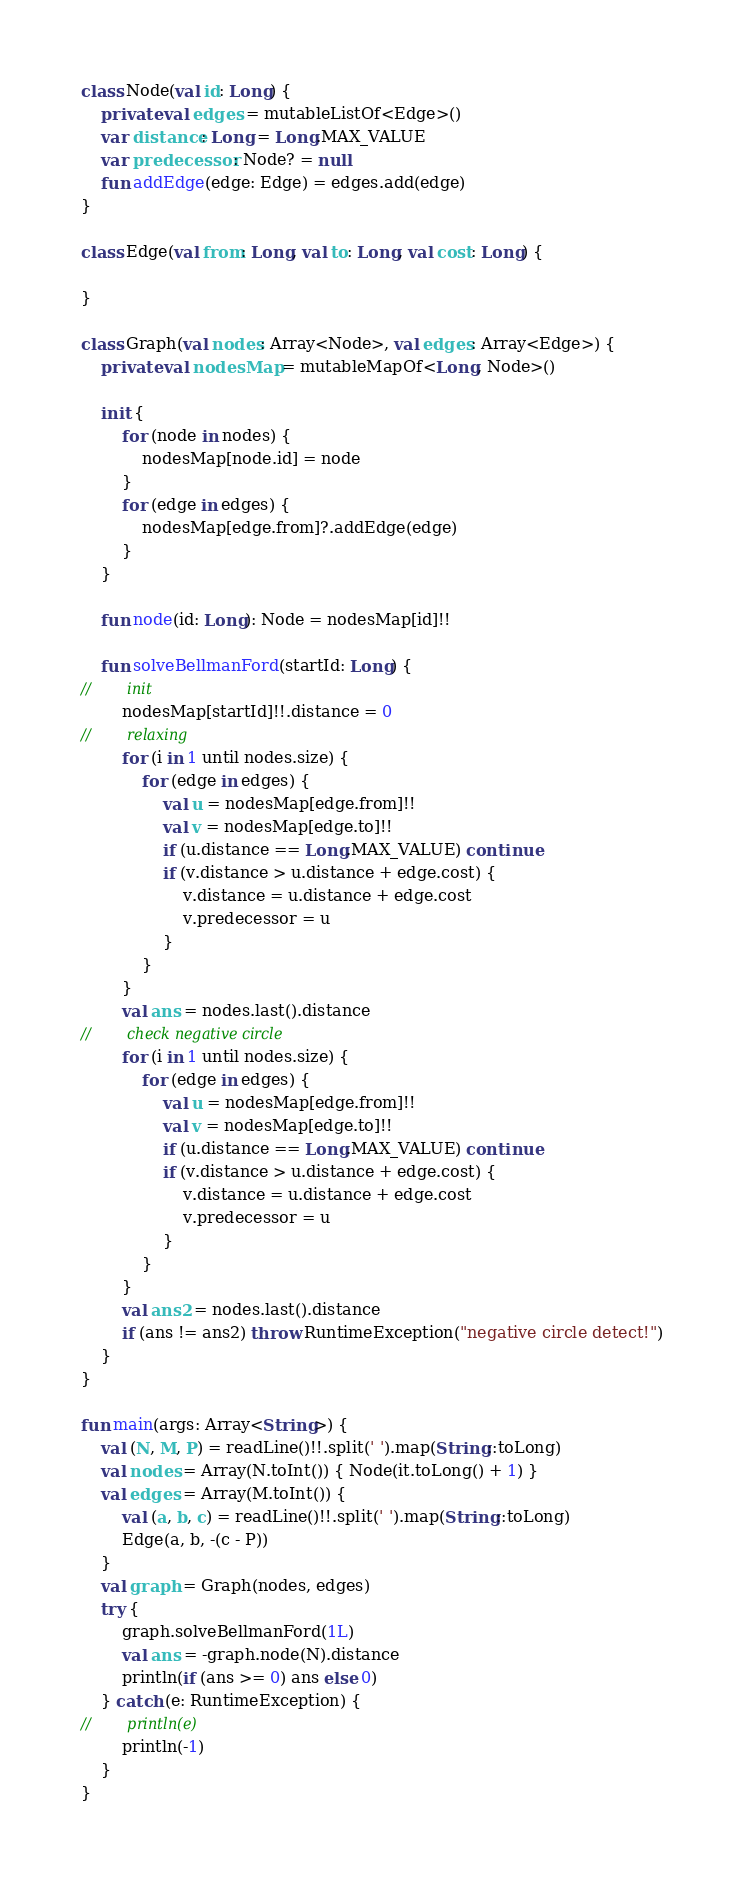<code> <loc_0><loc_0><loc_500><loc_500><_Kotlin_>class Node(val id: Long) {
    private val edges = mutableListOf<Edge>()
    var distance: Long = Long.MAX_VALUE
    var predecessor: Node? = null
    fun addEdge(edge: Edge) = edges.add(edge)
}

class Edge(val from: Long, val to: Long, val cost: Long) {

}

class Graph(val nodes: Array<Node>, val edges: Array<Edge>) {
    private val nodesMap = mutableMapOf<Long, Node>()

    init {
        for (node in nodes) {
            nodesMap[node.id] = node
        }
        for (edge in edges) {
            nodesMap[edge.from]?.addEdge(edge)
        }
    }

    fun node(id: Long): Node = nodesMap[id]!!

    fun solveBellmanFord(startId: Long) {
//        init
        nodesMap[startId]!!.distance = 0
//        relaxing
        for (i in 1 until nodes.size) {
            for (edge in edges) {
                val u = nodesMap[edge.from]!!
                val v = nodesMap[edge.to]!!
                if (u.distance == Long.MAX_VALUE) continue
                if (v.distance > u.distance + edge.cost) {
                    v.distance = u.distance + edge.cost
                    v.predecessor = u
                }
            }
        }
        val ans = nodes.last().distance
//        check negative circle
        for (i in 1 until nodes.size) {
            for (edge in edges) {
                val u = nodesMap[edge.from]!!
                val v = nodesMap[edge.to]!!
                if (u.distance == Long.MAX_VALUE) continue
                if (v.distance > u.distance + edge.cost) {
                    v.distance = u.distance + edge.cost
                    v.predecessor = u
                }
            }
        }
        val ans2 = nodes.last().distance
        if (ans != ans2) throw RuntimeException("negative circle detect!")
    }
}

fun main(args: Array<String>) {
    val (N, M, P) = readLine()!!.split(' ').map(String::toLong)
    val nodes = Array(N.toInt()) { Node(it.toLong() + 1) }
    val edges = Array(M.toInt()) {
        val (a, b, c) = readLine()!!.split(' ').map(String::toLong)
        Edge(a, b, -(c - P))
    }
    val graph = Graph(nodes, edges)
    try {
        graph.solveBellmanFord(1L)
        val ans = -graph.node(N).distance
        println(if (ans >= 0) ans else 0)
    } catch (e: RuntimeException) {
//        println(e)
        println(-1)
    }
}
</code> 